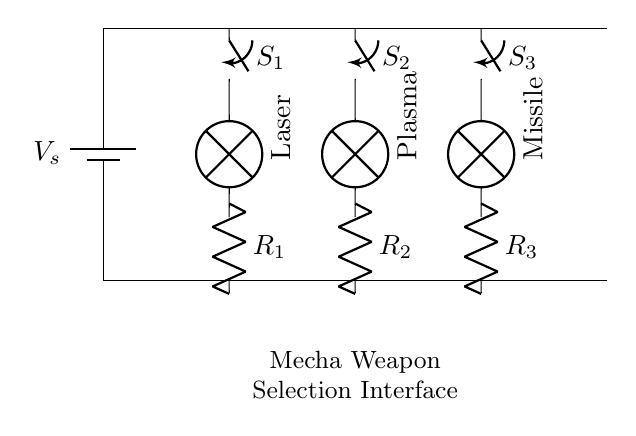What type of circuit is depicted in the diagram? The diagram shows a parallel circuit where multiple switches are connected to their respective components in parallel. Each switch controls a different weapon, allowing for selective activation.
Answer: parallel circuit How many switches are present in the circuit? There are three switches labeled S1, S2, and S3, each corresponding to a different weapon.
Answer: three switches What is the function of the component labeled 'Laser'? The 'Laser' represents one of the mecha’s weapon systems, and it is activated by the switch labeled S1. When S1 is closed, the laser circuit completes, allowing current to flow and the weapon to activate.
Answer: weapon system Which components are connected to switch S2? Switch S2 is connected to the 'Plasma' lamp and resistor R2. This configuration enables the activation of the Plasma weapon when S2 is closed.
Answer: Plasma and R2 What happens when all switches are closed in this circuit? When all switches (S1, S2, S3) are closed, all weapon systems (Laser, Plasma, Missile) can operate simultaneously, utilizing the shared voltage source.
Answer: All weapons activate What is the voltage source in this circuit? The diagram indicates a voltage source labeled V_s, which provides power to the entire circuit and allows the activation of the connected components.
Answer: V_s 